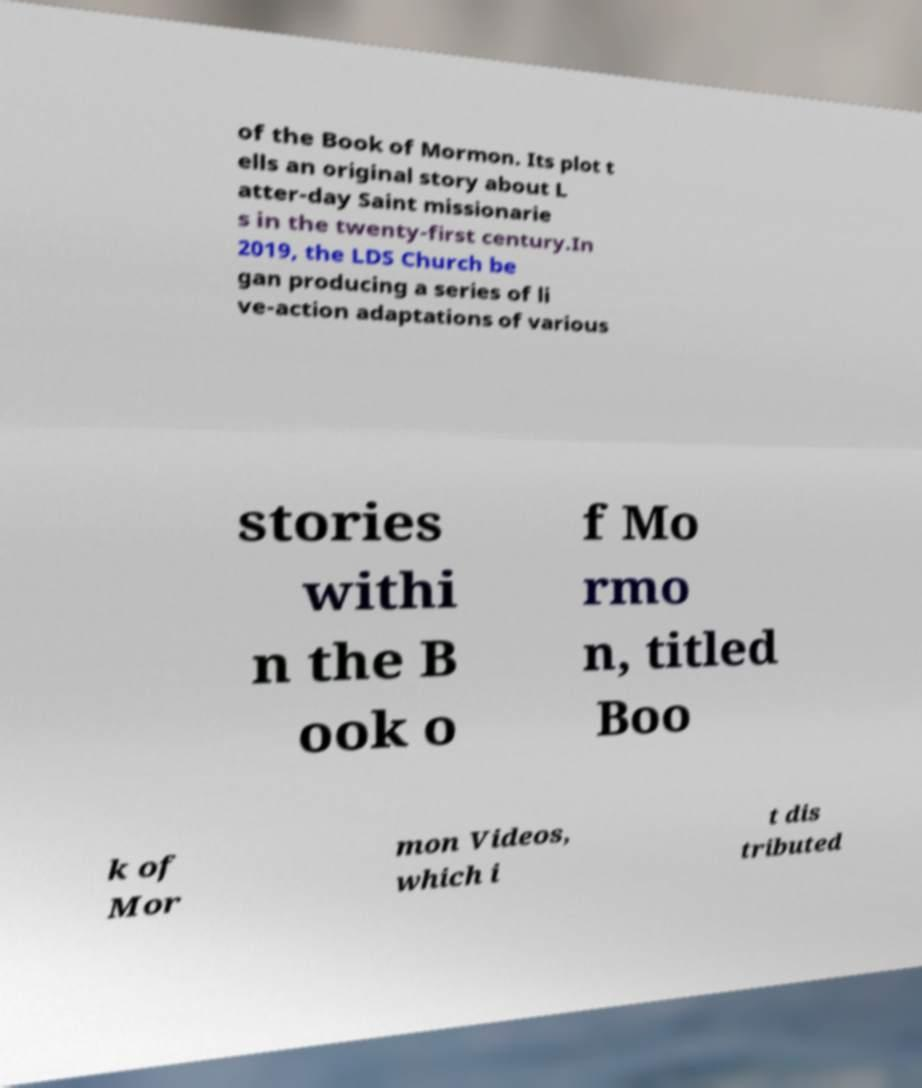For documentation purposes, I need the text within this image transcribed. Could you provide that? of the Book of Mormon. Its plot t ells an original story about L atter-day Saint missionarie s in the twenty-first century.In 2019, the LDS Church be gan producing a series of li ve-action adaptations of various stories withi n the B ook o f Mo rmo n, titled Boo k of Mor mon Videos, which i t dis tributed 